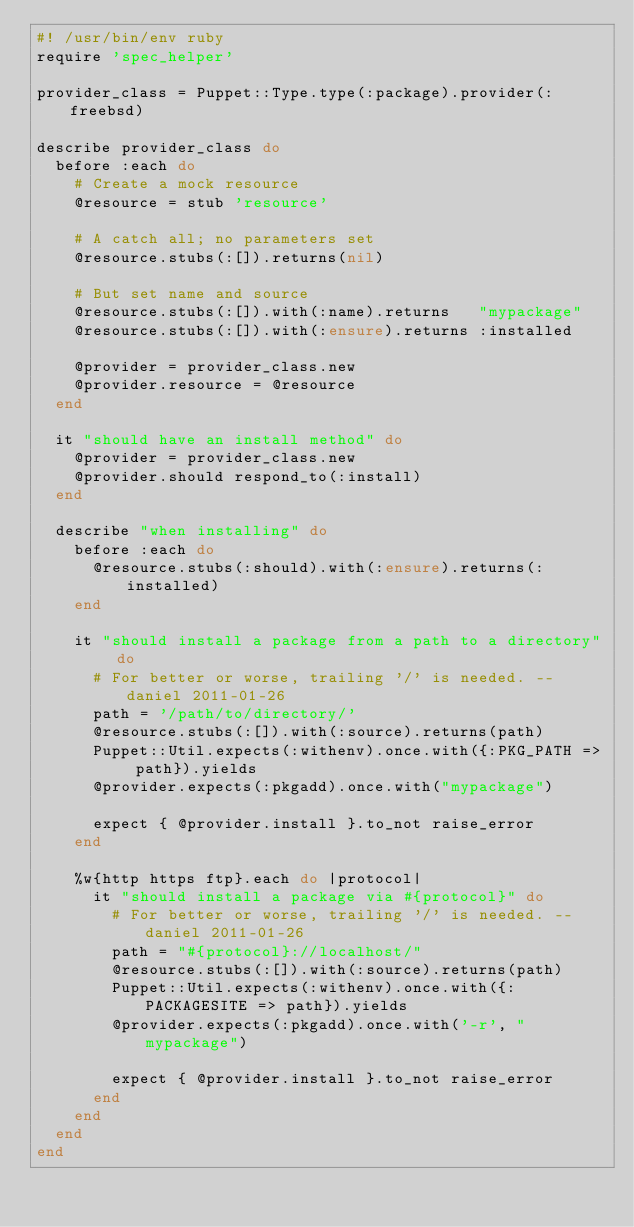Convert code to text. <code><loc_0><loc_0><loc_500><loc_500><_Ruby_>#! /usr/bin/env ruby
require 'spec_helper'

provider_class = Puppet::Type.type(:package).provider(:freebsd)

describe provider_class do
  before :each do
    # Create a mock resource
    @resource = stub 'resource'

    # A catch all; no parameters set
    @resource.stubs(:[]).returns(nil)

    # But set name and source
    @resource.stubs(:[]).with(:name).returns   "mypackage"
    @resource.stubs(:[]).with(:ensure).returns :installed

    @provider = provider_class.new
    @provider.resource = @resource
  end

  it "should have an install method" do
    @provider = provider_class.new
    @provider.should respond_to(:install)
  end

  describe "when installing" do
    before :each do
      @resource.stubs(:should).with(:ensure).returns(:installed)
    end

    it "should install a package from a path to a directory" do
      # For better or worse, trailing '/' is needed. --daniel 2011-01-26
      path = '/path/to/directory/'
      @resource.stubs(:[]).with(:source).returns(path)
      Puppet::Util.expects(:withenv).once.with({:PKG_PATH => path}).yields
      @provider.expects(:pkgadd).once.with("mypackage")

      expect { @provider.install }.to_not raise_error
    end

    %w{http https ftp}.each do |protocol|
      it "should install a package via #{protocol}" do
        # For better or worse, trailing '/' is needed. --daniel 2011-01-26
        path = "#{protocol}://localhost/"
        @resource.stubs(:[]).with(:source).returns(path)
        Puppet::Util.expects(:withenv).once.with({:PACKAGESITE => path}).yields
        @provider.expects(:pkgadd).once.with('-r', "mypackage")

        expect { @provider.install }.to_not raise_error
      end
    end
  end
end
</code> 